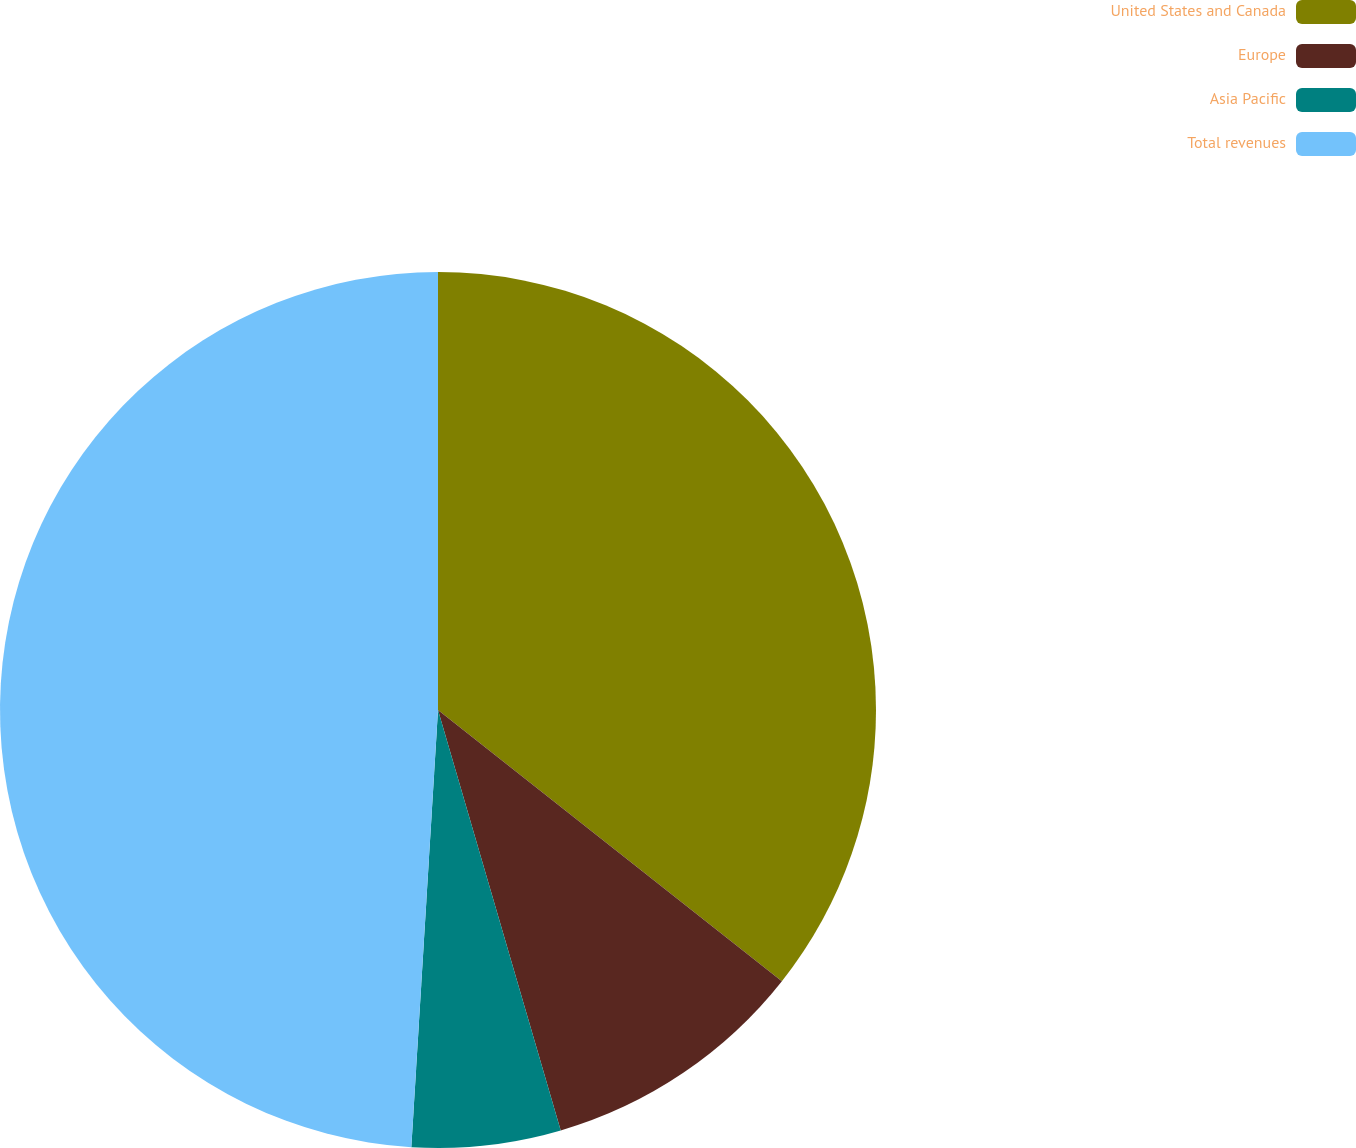Convert chart. <chart><loc_0><loc_0><loc_500><loc_500><pie_chart><fcel>United States and Canada<fcel>Europe<fcel>Asia Pacific<fcel>Total revenues<nl><fcel>35.63%<fcel>9.85%<fcel>5.49%<fcel>49.03%<nl></chart> 